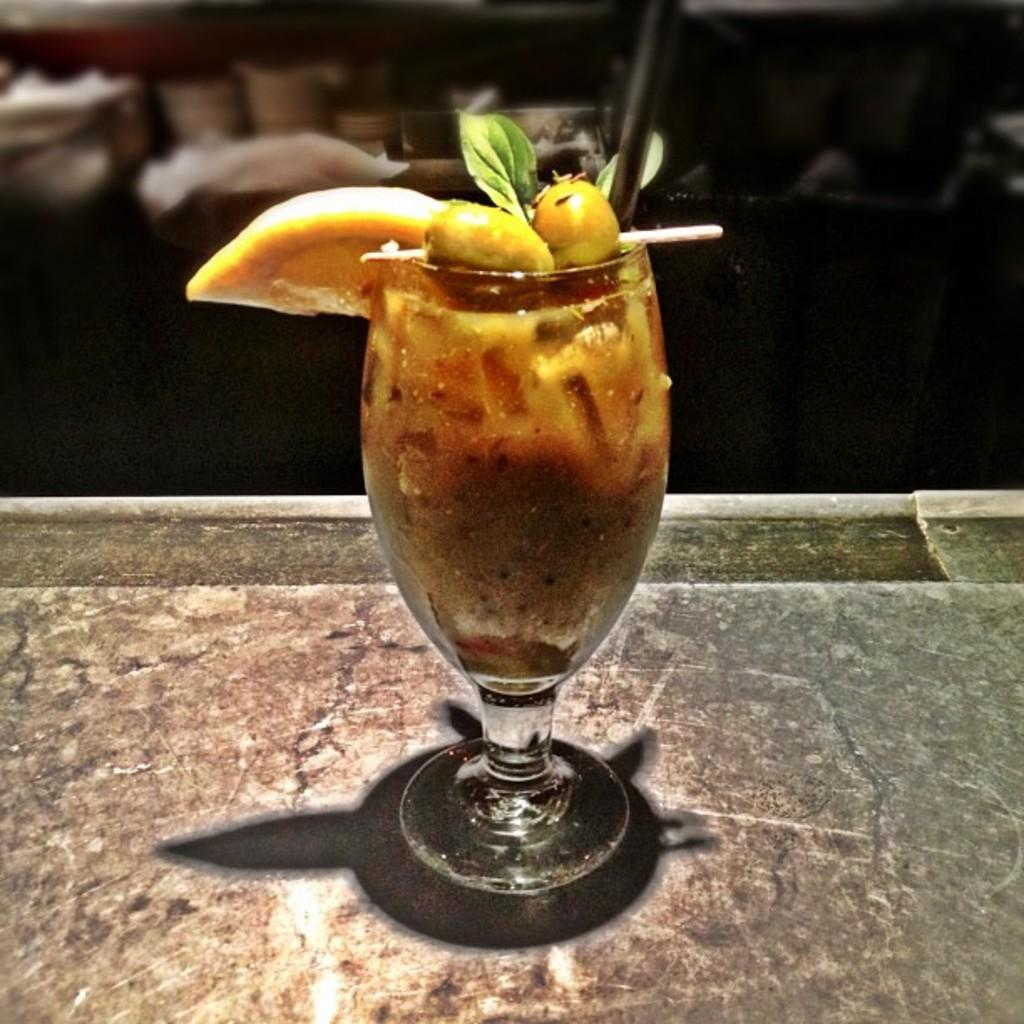What is in the glass that is visible in the image? There is a juice glass in the image. Where is the juice glass located? The juice glass is on a tray. What type of furniture can be seen in the background of the image? There are tables and chairs visible in the background of the image. What sound does the desk make in the image? There is no desk present in the image, so it cannot make any sound. 